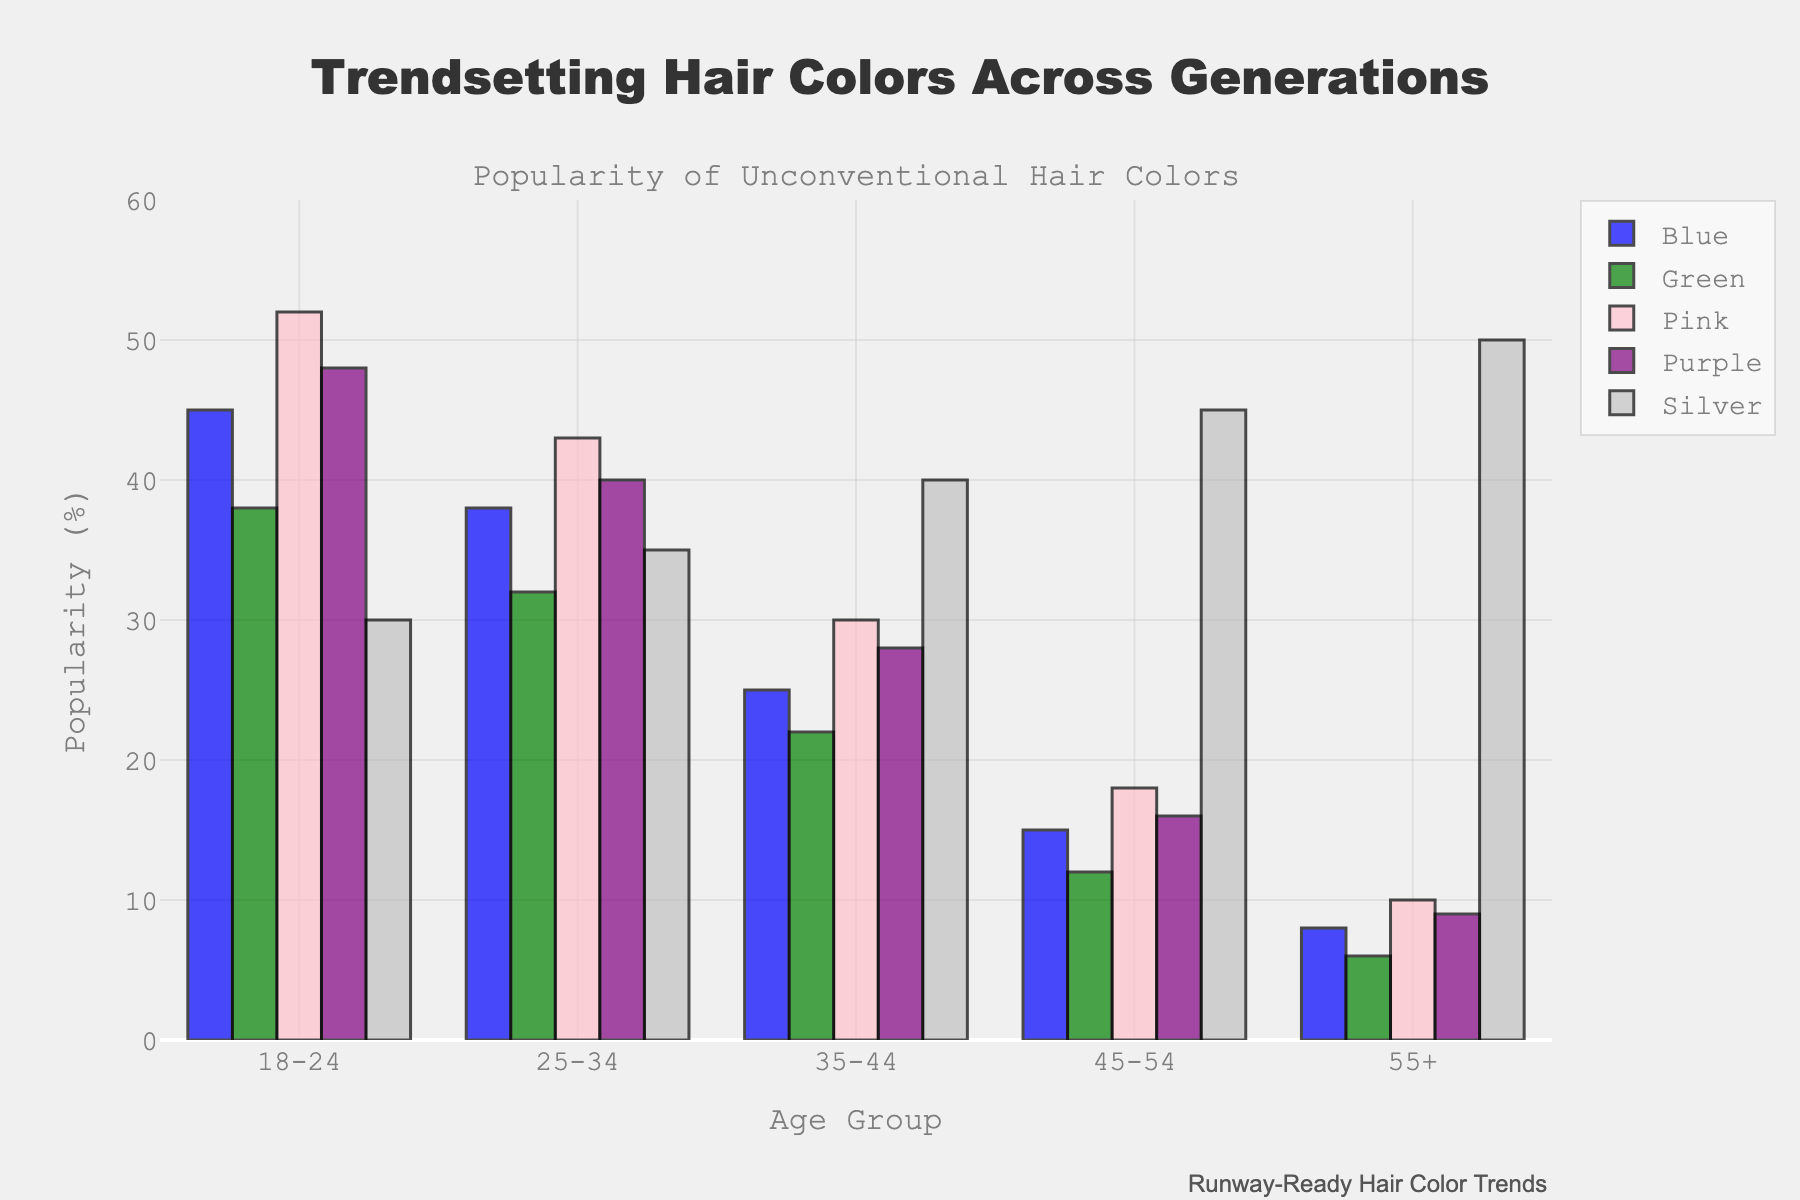What's the most popular hair color among the 18-24 age group? The highest bar among the colors for the 18-24 age group represents the most popular color. Here, Pink has the highest percentage at 52%.
Answer: Pink How does the popularity of Blue hair color change across age groups? Observing the heights of the Blue bars in sequence from 18-24 to 55+, the popularity decreases: 45%, 38%, 25%, 15%, 8%.
Answer: Decreases Which age group shows the greatest interest in the Silver hair color? The tallest Silver bar among all age groups indicates the greatest interest. The bar for the 55+ age group is the highest at 50%.
Answer: 55+ What's the difference in popularity between Pink and Green in the 25-34 age group? Subtract the percentage of Green from Pink in the 25-34 age group: 43% (Pink) - 32% (Green) = 11%.
Answer: 11% Are there any age groups where Purple is more popular than Blue? Compare the Purple and Blue percentages for each age group. In all age groups, Blue's percentages are higher than Purple's.
Answer: No What's the average popularity of Green hair color across all age groups? Sum the percentages of Green for all age groups and divide by the number of age groups: (38% + 32% + 22% + 12% + 6%) / 5 = 22%.
Answer: 22% Which color is least popular among the 45-54 age group? The shortest bar for the 45-54 age group corresponds to Green with 12%.
Answer: Green What is the total popularity percentage of all hair colors combined in the 35-44 age group? Sum the percentages of all colors for the 35-44 age group: 25% (Blue) + 22% (Green) + 30% (Pink) + 28% (Purple) + 40% (Silver) = 145%.
Answer: 145% By how much does the popularity of Silver hair color increase from the 18-24 group to the 55+ group? Subtract the percentage of Silver in the 18-24 age group from that in the 55+ age group: 50% (55+) - 30% (18-24) = 20%.
Answer: 20% Which hair color sees a steady increase in popularity with increasing age? Observing all colors' trends across age groups, Silver shows a steady increase from 30% in 18-24 to 50% in 55+.
Answer: Silver 